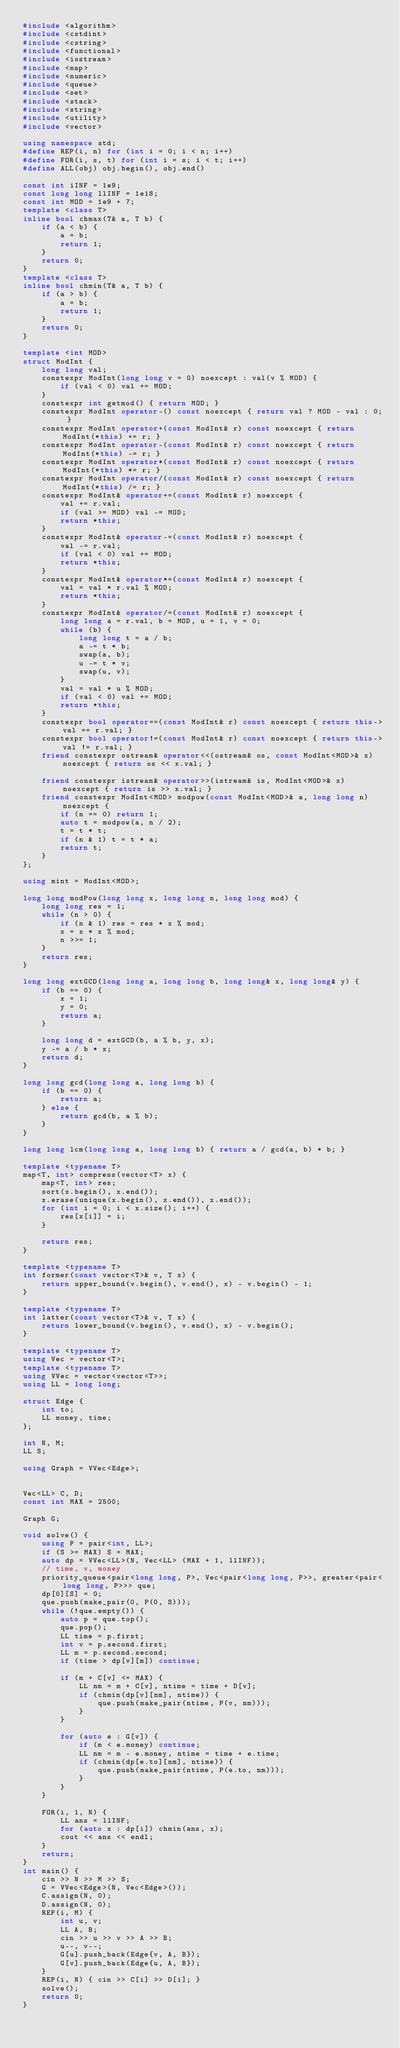<code> <loc_0><loc_0><loc_500><loc_500><_C++_>#include <algorithm>
#include <cstdint>
#include <cstring>
#include <functional>
#include <iostream>
#include <map>
#include <numeric>
#include <queue>
#include <set>
#include <stack>
#include <string>
#include <utility>
#include <vector>

using namespace std;
#define REP(i, n) for (int i = 0; i < n; i++)
#define FOR(i, s, t) for (int i = s; i < t; i++)
#define ALL(obj) obj.begin(), obj.end()

const int iINF = 1e9;
const long long llINF = 1e18;
const int MOD = 1e9 + 7;
template <class T>
inline bool chmax(T& a, T b) {
    if (a < b) {
        a = b;
        return 1;
    }
    return 0;
}
template <class T>
inline bool chmin(T& a, T b) {
    if (a > b) {
        a = b;
        return 1;
    }
    return 0;
}

template <int MOD>
struct ModInt {
    long long val;
    constexpr ModInt(long long v = 0) noexcept : val(v % MOD) {
        if (val < 0) val += MOD;
    }
    constexpr int getmod() { return MOD; }
    constexpr ModInt operator-() const noexcept { return val ? MOD - val : 0; }
    constexpr ModInt operator+(const ModInt& r) const noexcept { return ModInt(*this) += r; }
    constexpr ModInt operator-(const ModInt& r) const noexcept { return ModInt(*this) -= r; }
    constexpr ModInt operator*(const ModInt& r) const noexcept { return ModInt(*this) *= r; }
    constexpr ModInt operator/(const ModInt& r) const noexcept { return ModInt(*this) /= r; }
    constexpr ModInt& operator+=(const ModInt& r) noexcept {
        val += r.val;
        if (val >= MOD) val -= MOD;
        return *this;
    }
    constexpr ModInt& operator-=(const ModInt& r) noexcept {
        val -= r.val;
        if (val < 0) val += MOD;
        return *this;
    }
    constexpr ModInt& operator*=(const ModInt& r) noexcept {
        val = val * r.val % MOD;
        return *this;
    }
    constexpr ModInt& operator/=(const ModInt& r) noexcept {
        long long a = r.val, b = MOD, u = 1, v = 0;
        while (b) {
            long long t = a / b;
            a -= t * b;
            swap(a, b);
            u -= t * v;
            swap(u, v);
        }
        val = val * u % MOD;
        if (val < 0) val += MOD;
        return *this;
    }
    constexpr bool operator==(const ModInt& r) const noexcept { return this->val == r.val; }
    constexpr bool operator!=(const ModInt& r) const noexcept { return this->val != r.val; }
    friend constexpr ostream& operator<<(ostream& os, const ModInt<MOD>& x) noexcept { return os << x.val; }

    friend constexpr istream& operator>>(istream& is, ModInt<MOD>& x) noexcept { return is >> x.val; }
    friend constexpr ModInt<MOD> modpow(const ModInt<MOD>& a, long long n) noexcept {
        if (n == 0) return 1;
        auto t = modpow(a, n / 2);
        t = t * t;
        if (n & 1) t = t * a;
        return t;
    }
};

using mint = ModInt<MOD>;

long long modPow(long long x, long long n, long long mod) {
    long long res = 1;
    while (n > 0) {
        if (n & 1) res = res * x % mod;
        x = x * x % mod;
        n >>= 1;
    }
    return res;
}

long long extGCD(long long a, long long b, long long& x, long long& y) {
    if (b == 0) {
        x = 1;
        y = 0;
        return a;
    }

    long long d = extGCD(b, a % b, y, x);
    y -= a / b * x;
    return d;
}

long long gcd(long long a, long long b) {
    if (b == 0) {
        return a;
    } else {
        return gcd(b, a % b);
    }
}

long long lcm(long long a, long long b) { return a / gcd(a, b) * b; }

template <typename T>
map<T, int> compress(vector<T> x) {
    map<T, int> res;
    sort(x.begin(), x.end());
    x.erase(unique(x.begin(), x.end()), x.end());
    for (int i = 0; i < x.size(); i++) {
        res[x[i]] = i;
    }

    return res;
}

template <typename T>
int former(const vector<T>& v, T x) {
    return upper_bound(v.begin(), v.end(), x) - v.begin() - 1;
}

template <typename T>
int latter(const vector<T>& v, T x) {
    return lower_bound(v.begin(), v.end(), x) - v.begin();
}

template <typename T>
using Vec = vector<T>;
template <typename T>
using VVec = vector<vector<T>>;
using LL = long long;

struct Edge {
    int to;
    LL money, time;
};

int N, M;
LL S;

using Graph = VVec<Edge>;


Vec<LL> C, D;
const int MAX = 2500;

Graph G;

void solve() {
    using P = pair<int, LL>;
    if (S >= MAX) S = MAX;
    auto dp = VVec<LL>(N, Vec<LL> (MAX + 1, llINF));
    // time, v, money
    priority_queue<pair<long long, P>, Vec<pair<long long, P>>, greater<pair<long long, P>>> que;
    dp[0][S] = 0;
    que.push(make_pair(0, P(0, S)));
    while (!que.empty()) {
        auto p = que.top();
        que.pop();
        LL time = p.first;
        int v = p.second.first;
        LL m = p.second.second;
        if (time > dp[v][m]) continue;

        if (m + C[v] <= MAX) {
            LL nm = m + C[v], ntime = time + D[v];
            if (chmin(dp[v][nm], ntime)) {
                que.push(make_pair(ntime, P(v, nm)));
            }
        }

        for (auto e : G[v]) {
            if (m < e.money) continue;
            LL nm = m - e.money, ntime = time + e.time;
            if (chmin(dp[e.to][nm], ntime)) {
                que.push(make_pair(ntime, P(e.to, nm)));
            }
        }
    }

    FOR(i, 1, N) {
        LL ans = llINF;
        for (auto x : dp[i]) chmin(ans, x);
        cout << ans << endl;
    }
    return;
}
int main() {
    cin >> N >> M >> S;
    G = VVec<Edge>(N, Vec<Edge>());
    C.assign(N, 0);
    D.assign(N, 0);
    REP(i, M) {
        int u, v;
        LL A, B;
        cin >> u >> v >> A >> B;
        u--, v--;
        G[u].push_back(Edge{v, A, B});
        G[v].push_back(Edge{u, A, B});
    }
    REP(i, N) { cin >> C[i] >> D[i]; }
    solve();
    return 0;
}</code> 